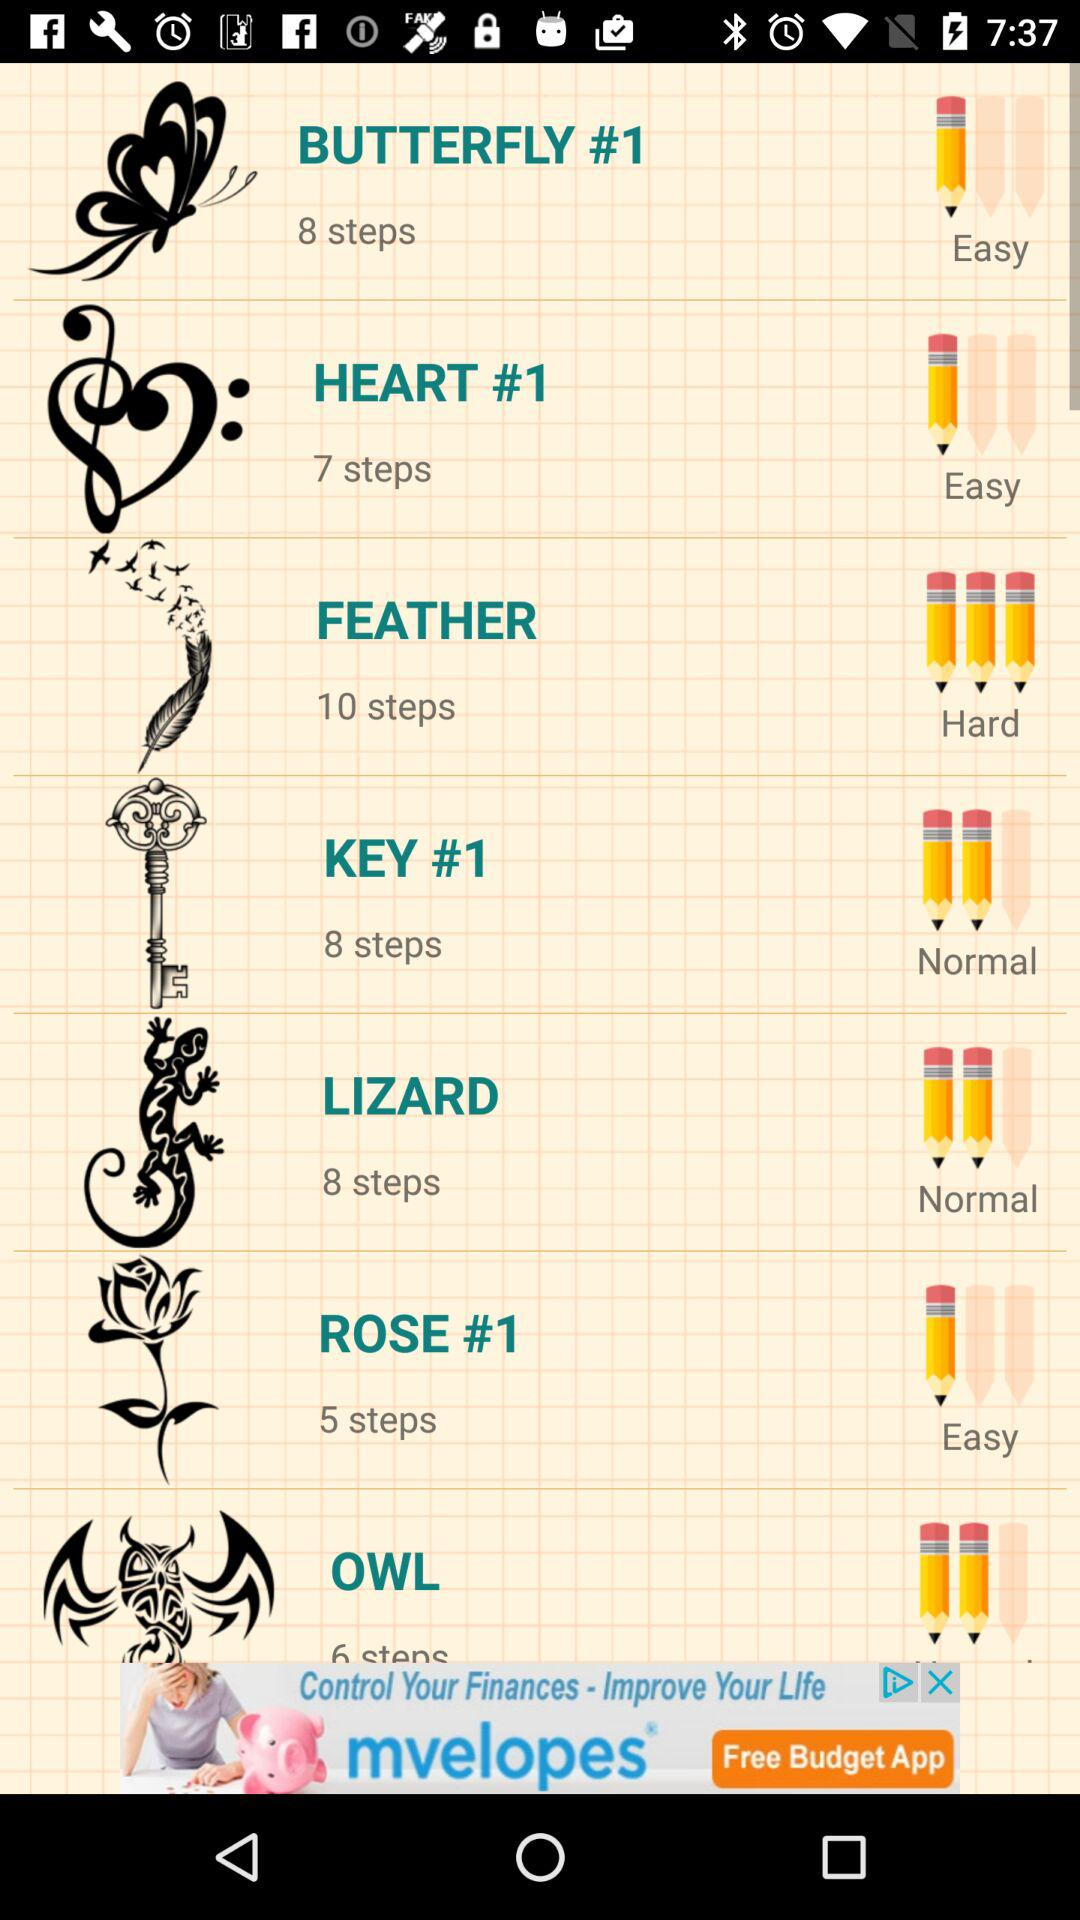How many of the items have a difficulty of 'Normal'?
Answer the question using a single word or phrase. 2 